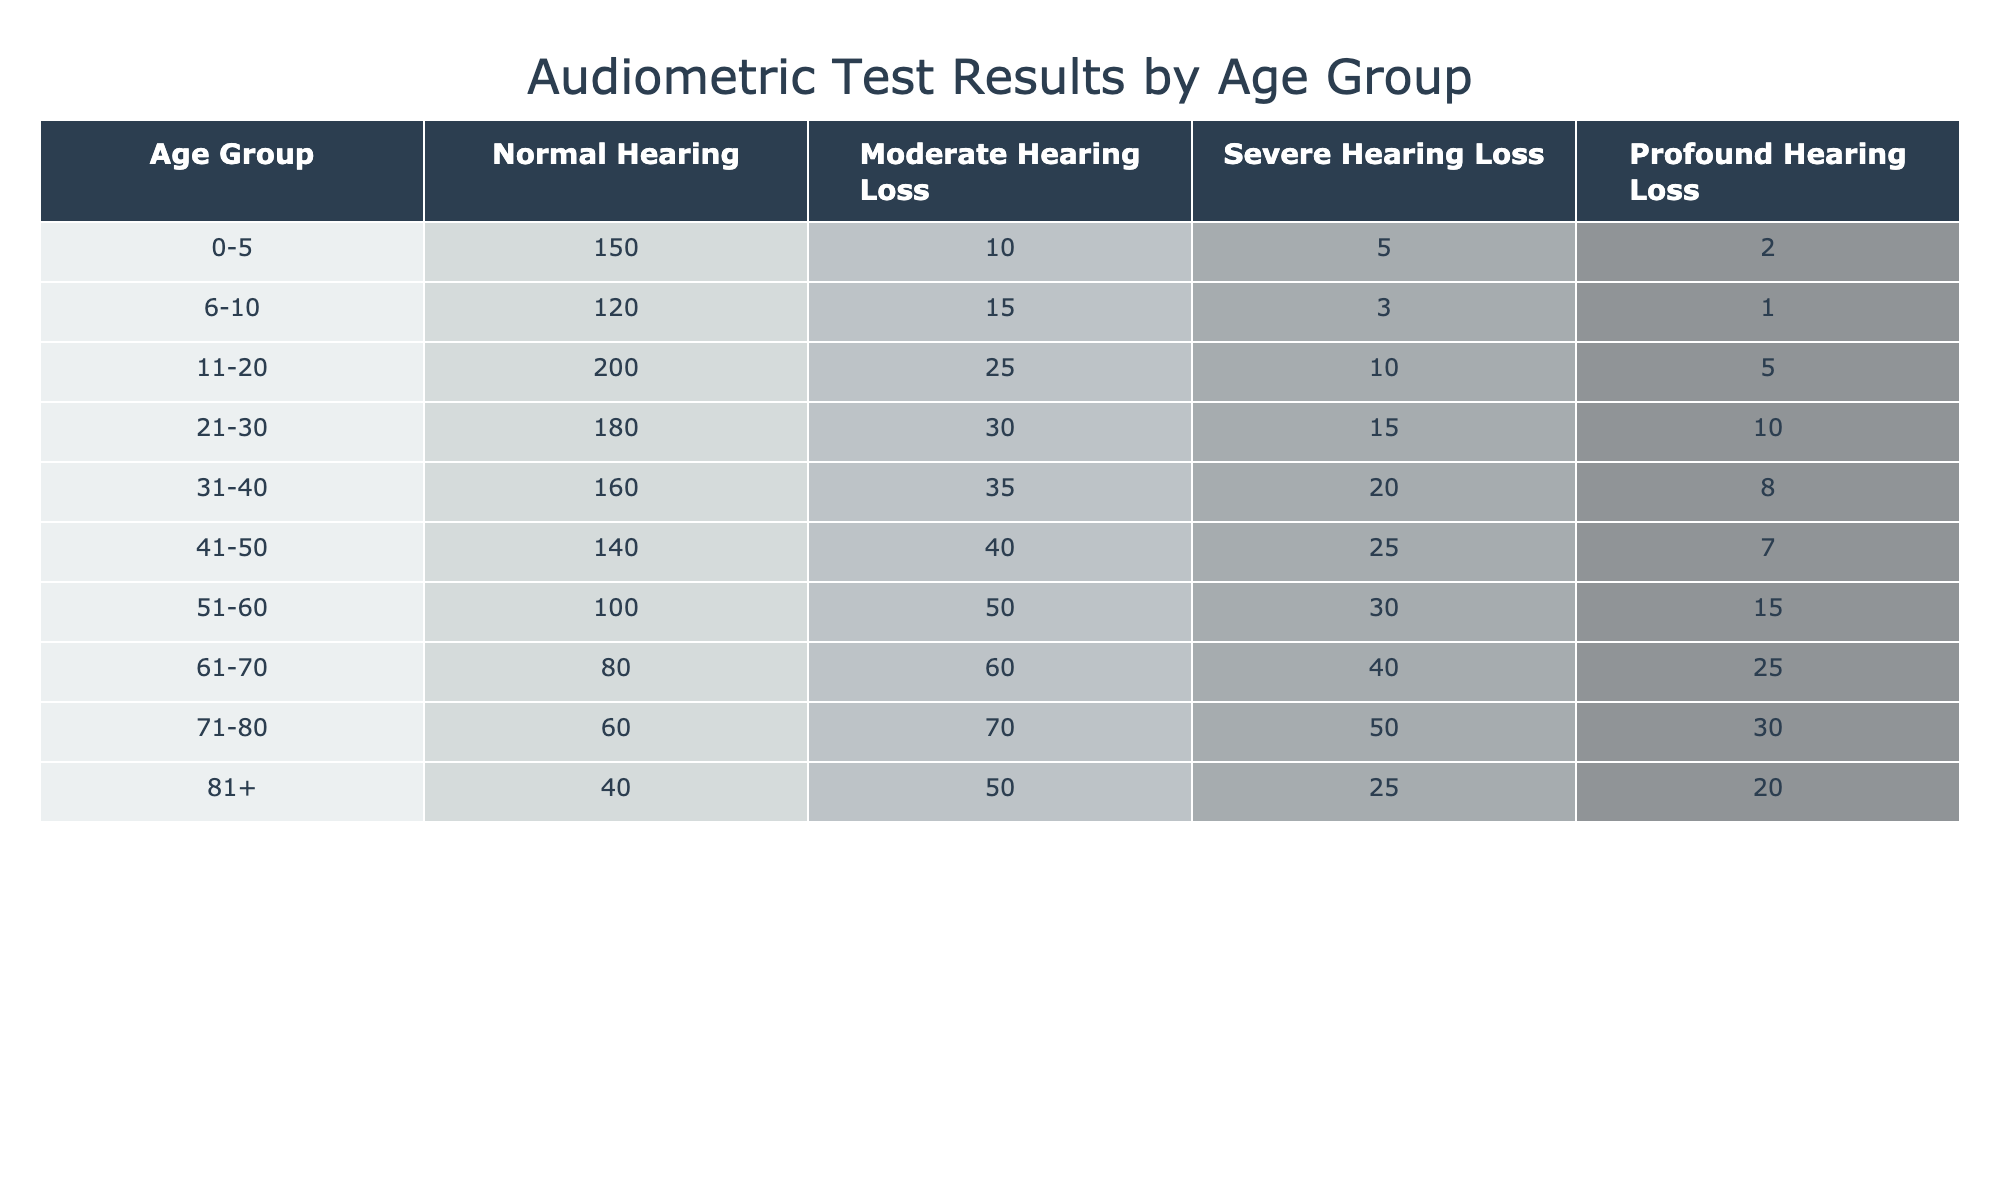What is the total number of individuals with normal hearing in the age group 31-40? From the table, we can see the number of individuals with normal hearing in the age group 31-40 is 160.
Answer: 160 How many individuals in the age group 61-70 have severe hearing loss? The table shows that in the age group 61-70, there are 40 individuals with severe hearing loss.
Answer: 40 For the age group 11-20, what is the combined total of individuals with moderate and profound hearing loss? By checking the table, we find 25 individuals with moderate hearing loss and 5 with profound hearing loss in this age group. Adding them gives us 25 + 5 = 30.
Answer: 30 Is the number of individuals with profound hearing loss greater in the age group 71-80 than in 51-60? In the age group 71-80, there are 30 individuals with profound hearing loss, while in the age group 51-60, there are 15. Since 30 is greater than 15, the answer is yes.
Answer: Yes What is the average number of individuals with moderate hearing loss across all age groups? To calculate the average, we first sum the number of individuals with moderate hearing loss across all age groups: 10 + 15 + 25 + 30 + 35 + 40 + 50 + 60 + 70 + 50 = 385. There are 10 age groups, so we divide 385 by 10, resulting in an average of 38.5.
Answer: 38.5 In which age group is the highest number of individuals with severe hearing loss found, and how many are there? Looking through the table, we see the maximum number of individuals with severe hearing loss occurs in the age group 51-60, with 30 individuals.
Answer: 51-60, 30 What percentage of individuals aged 0-5 have any form of hearing loss? In the age group 0-5, there are a total of 10 (moderate) + 5 (severe) + 2 (profound) = 17 individuals with any form of hearing loss, out of 150 total individuals. Thus, the percentage is (17/150)*100 = 11.33%.
Answer: 11.33% Is there any age group where the number of individuals with normal hearing exceeds 200? By reviewing the table, we see that the age group 11-20 has 200 individuals with normal hearing, which does not exceed but equals 200. Thus, the answer is no.
Answer: No What is the difference in the number of individuals with moderate hearing loss between the age groups 51-60 and 31-40? From the table, we see that there are 50 individuals in the 51-60 age group and 35 in the 31-40 age group. The difference is 50 - 35 = 15.
Answer: 15 